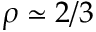Convert formula to latex. <formula><loc_0><loc_0><loc_500><loc_500>\rho \simeq 2 / 3</formula> 